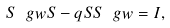Convert formula to latex. <formula><loc_0><loc_0><loc_500><loc_500>S \ g w S - q S S \ g w = I ,</formula> 